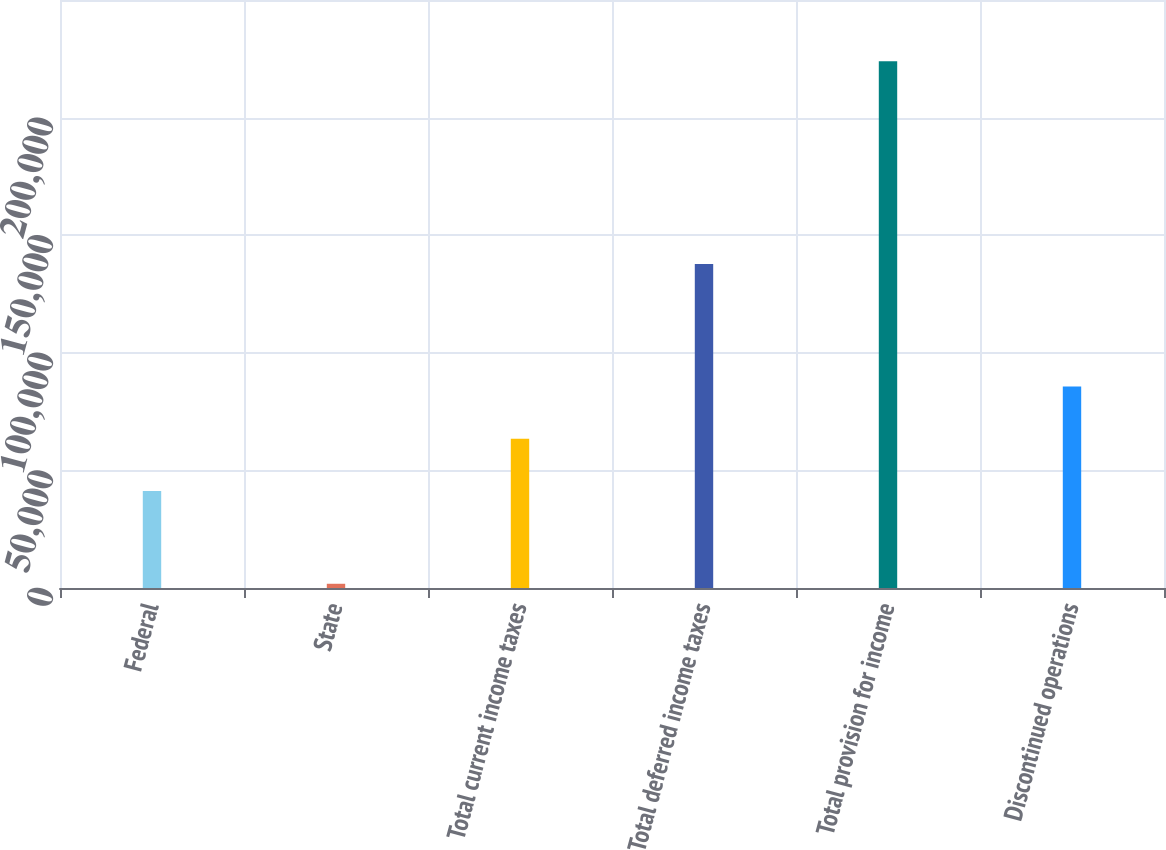Convert chart. <chart><loc_0><loc_0><loc_500><loc_500><bar_chart><fcel>Federal<fcel>State<fcel>Total current income taxes<fcel>Total deferred income taxes<fcel>Total provision for income<fcel>Discontinued operations<nl><fcel>41246<fcel>1798<fcel>63460.6<fcel>137714<fcel>223944<fcel>85675.2<nl></chart> 